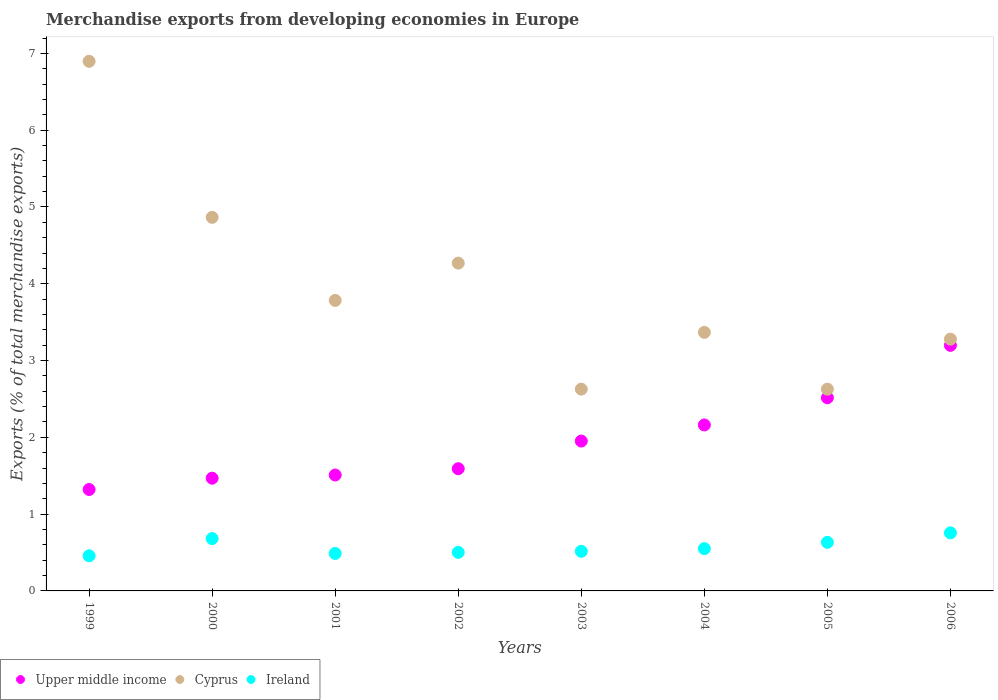How many different coloured dotlines are there?
Offer a terse response. 3. What is the percentage of total merchandise exports in Cyprus in 2005?
Your answer should be compact. 2.63. Across all years, what is the maximum percentage of total merchandise exports in Upper middle income?
Keep it short and to the point. 3.2. Across all years, what is the minimum percentage of total merchandise exports in Ireland?
Offer a very short reply. 0.46. In which year was the percentage of total merchandise exports in Ireland maximum?
Give a very brief answer. 2006. In which year was the percentage of total merchandise exports in Upper middle income minimum?
Keep it short and to the point. 1999. What is the total percentage of total merchandise exports in Ireland in the graph?
Your answer should be very brief. 4.58. What is the difference between the percentage of total merchandise exports in Ireland in 2001 and that in 2003?
Offer a terse response. -0.03. What is the difference between the percentage of total merchandise exports in Upper middle income in 2005 and the percentage of total merchandise exports in Ireland in 2000?
Your answer should be compact. 1.83. What is the average percentage of total merchandise exports in Upper middle income per year?
Your answer should be compact. 1.96. In the year 2000, what is the difference between the percentage of total merchandise exports in Ireland and percentage of total merchandise exports in Upper middle income?
Provide a succinct answer. -0.79. In how many years, is the percentage of total merchandise exports in Cyprus greater than 4.6 %?
Provide a succinct answer. 2. What is the ratio of the percentage of total merchandise exports in Ireland in 2000 to that in 2006?
Keep it short and to the point. 0.9. What is the difference between the highest and the second highest percentage of total merchandise exports in Ireland?
Offer a terse response. 0.07. What is the difference between the highest and the lowest percentage of total merchandise exports in Cyprus?
Make the answer very short. 4.27. In how many years, is the percentage of total merchandise exports in Upper middle income greater than the average percentage of total merchandise exports in Upper middle income taken over all years?
Your answer should be compact. 3. Is the sum of the percentage of total merchandise exports in Ireland in 2003 and 2005 greater than the maximum percentage of total merchandise exports in Cyprus across all years?
Make the answer very short. No. Is it the case that in every year, the sum of the percentage of total merchandise exports in Ireland and percentage of total merchandise exports in Cyprus  is greater than the percentage of total merchandise exports in Upper middle income?
Make the answer very short. Yes. Does the percentage of total merchandise exports in Upper middle income monotonically increase over the years?
Offer a terse response. Yes. Is the percentage of total merchandise exports in Cyprus strictly less than the percentage of total merchandise exports in Upper middle income over the years?
Offer a very short reply. No. How many dotlines are there?
Give a very brief answer. 3. How many years are there in the graph?
Keep it short and to the point. 8. What is the difference between two consecutive major ticks on the Y-axis?
Offer a terse response. 1. Are the values on the major ticks of Y-axis written in scientific E-notation?
Keep it short and to the point. No. Does the graph contain grids?
Offer a very short reply. No. How many legend labels are there?
Provide a succinct answer. 3. What is the title of the graph?
Provide a short and direct response. Merchandise exports from developing economies in Europe. Does "East Asia (developing only)" appear as one of the legend labels in the graph?
Give a very brief answer. No. What is the label or title of the X-axis?
Make the answer very short. Years. What is the label or title of the Y-axis?
Ensure brevity in your answer.  Exports (% of total merchandise exports). What is the Exports (% of total merchandise exports) of Upper middle income in 1999?
Provide a short and direct response. 1.32. What is the Exports (% of total merchandise exports) in Cyprus in 1999?
Keep it short and to the point. 6.9. What is the Exports (% of total merchandise exports) in Ireland in 1999?
Give a very brief answer. 0.46. What is the Exports (% of total merchandise exports) in Upper middle income in 2000?
Your answer should be compact. 1.47. What is the Exports (% of total merchandise exports) in Cyprus in 2000?
Provide a succinct answer. 4.87. What is the Exports (% of total merchandise exports) of Ireland in 2000?
Offer a terse response. 0.68. What is the Exports (% of total merchandise exports) of Upper middle income in 2001?
Keep it short and to the point. 1.51. What is the Exports (% of total merchandise exports) of Cyprus in 2001?
Give a very brief answer. 3.78. What is the Exports (% of total merchandise exports) of Ireland in 2001?
Offer a very short reply. 0.49. What is the Exports (% of total merchandise exports) of Upper middle income in 2002?
Make the answer very short. 1.59. What is the Exports (% of total merchandise exports) of Cyprus in 2002?
Provide a succinct answer. 4.27. What is the Exports (% of total merchandise exports) of Ireland in 2002?
Give a very brief answer. 0.5. What is the Exports (% of total merchandise exports) of Upper middle income in 2003?
Provide a short and direct response. 1.95. What is the Exports (% of total merchandise exports) of Cyprus in 2003?
Give a very brief answer. 2.63. What is the Exports (% of total merchandise exports) in Ireland in 2003?
Ensure brevity in your answer.  0.52. What is the Exports (% of total merchandise exports) of Upper middle income in 2004?
Offer a terse response. 2.16. What is the Exports (% of total merchandise exports) in Cyprus in 2004?
Provide a short and direct response. 3.37. What is the Exports (% of total merchandise exports) of Ireland in 2004?
Offer a very short reply. 0.55. What is the Exports (% of total merchandise exports) of Upper middle income in 2005?
Provide a succinct answer. 2.52. What is the Exports (% of total merchandise exports) of Cyprus in 2005?
Ensure brevity in your answer.  2.63. What is the Exports (% of total merchandise exports) in Ireland in 2005?
Provide a succinct answer. 0.63. What is the Exports (% of total merchandise exports) in Upper middle income in 2006?
Your answer should be compact. 3.2. What is the Exports (% of total merchandise exports) of Cyprus in 2006?
Provide a succinct answer. 3.28. What is the Exports (% of total merchandise exports) of Ireland in 2006?
Your answer should be very brief. 0.76. Across all years, what is the maximum Exports (% of total merchandise exports) of Upper middle income?
Your answer should be compact. 3.2. Across all years, what is the maximum Exports (% of total merchandise exports) of Cyprus?
Ensure brevity in your answer.  6.9. Across all years, what is the maximum Exports (% of total merchandise exports) in Ireland?
Your answer should be very brief. 0.76. Across all years, what is the minimum Exports (% of total merchandise exports) in Upper middle income?
Your answer should be compact. 1.32. Across all years, what is the minimum Exports (% of total merchandise exports) in Cyprus?
Make the answer very short. 2.63. Across all years, what is the minimum Exports (% of total merchandise exports) of Ireland?
Give a very brief answer. 0.46. What is the total Exports (% of total merchandise exports) of Upper middle income in the graph?
Your answer should be compact. 15.72. What is the total Exports (% of total merchandise exports) in Cyprus in the graph?
Offer a terse response. 31.72. What is the total Exports (% of total merchandise exports) in Ireland in the graph?
Offer a terse response. 4.58. What is the difference between the Exports (% of total merchandise exports) in Upper middle income in 1999 and that in 2000?
Offer a terse response. -0.15. What is the difference between the Exports (% of total merchandise exports) in Cyprus in 1999 and that in 2000?
Provide a succinct answer. 2.03. What is the difference between the Exports (% of total merchandise exports) in Ireland in 1999 and that in 2000?
Your response must be concise. -0.22. What is the difference between the Exports (% of total merchandise exports) in Upper middle income in 1999 and that in 2001?
Keep it short and to the point. -0.19. What is the difference between the Exports (% of total merchandise exports) in Cyprus in 1999 and that in 2001?
Ensure brevity in your answer.  3.11. What is the difference between the Exports (% of total merchandise exports) of Ireland in 1999 and that in 2001?
Your response must be concise. -0.03. What is the difference between the Exports (% of total merchandise exports) in Upper middle income in 1999 and that in 2002?
Your answer should be compact. -0.27. What is the difference between the Exports (% of total merchandise exports) of Cyprus in 1999 and that in 2002?
Your answer should be very brief. 2.63. What is the difference between the Exports (% of total merchandise exports) in Ireland in 1999 and that in 2002?
Offer a very short reply. -0.04. What is the difference between the Exports (% of total merchandise exports) of Upper middle income in 1999 and that in 2003?
Keep it short and to the point. -0.63. What is the difference between the Exports (% of total merchandise exports) of Cyprus in 1999 and that in 2003?
Keep it short and to the point. 4.27. What is the difference between the Exports (% of total merchandise exports) of Ireland in 1999 and that in 2003?
Provide a short and direct response. -0.06. What is the difference between the Exports (% of total merchandise exports) in Upper middle income in 1999 and that in 2004?
Ensure brevity in your answer.  -0.84. What is the difference between the Exports (% of total merchandise exports) in Cyprus in 1999 and that in 2004?
Provide a short and direct response. 3.53. What is the difference between the Exports (% of total merchandise exports) of Ireland in 1999 and that in 2004?
Make the answer very short. -0.09. What is the difference between the Exports (% of total merchandise exports) of Upper middle income in 1999 and that in 2005?
Ensure brevity in your answer.  -1.19. What is the difference between the Exports (% of total merchandise exports) in Cyprus in 1999 and that in 2005?
Give a very brief answer. 4.27. What is the difference between the Exports (% of total merchandise exports) of Ireland in 1999 and that in 2005?
Your answer should be very brief. -0.17. What is the difference between the Exports (% of total merchandise exports) of Upper middle income in 1999 and that in 2006?
Give a very brief answer. -1.88. What is the difference between the Exports (% of total merchandise exports) of Cyprus in 1999 and that in 2006?
Offer a terse response. 3.62. What is the difference between the Exports (% of total merchandise exports) in Ireland in 1999 and that in 2006?
Your answer should be compact. -0.3. What is the difference between the Exports (% of total merchandise exports) of Upper middle income in 2000 and that in 2001?
Your answer should be very brief. -0.04. What is the difference between the Exports (% of total merchandise exports) in Cyprus in 2000 and that in 2001?
Make the answer very short. 1.08. What is the difference between the Exports (% of total merchandise exports) of Ireland in 2000 and that in 2001?
Make the answer very short. 0.19. What is the difference between the Exports (% of total merchandise exports) in Upper middle income in 2000 and that in 2002?
Your answer should be very brief. -0.12. What is the difference between the Exports (% of total merchandise exports) in Cyprus in 2000 and that in 2002?
Offer a very short reply. 0.6. What is the difference between the Exports (% of total merchandise exports) in Ireland in 2000 and that in 2002?
Make the answer very short. 0.18. What is the difference between the Exports (% of total merchandise exports) of Upper middle income in 2000 and that in 2003?
Make the answer very short. -0.48. What is the difference between the Exports (% of total merchandise exports) in Cyprus in 2000 and that in 2003?
Your response must be concise. 2.24. What is the difference between the Exports (% of total merchandise exports) in Ireland in 2000 and that in 2003?
Your response must be concise. 0.17. What is the difference between the Exports (% of total merchandise exports) in Upper middle income in 2000 and that in 2004?
Make the answer very short. -0.69. What is the difference between the Exports (% of total merchandise exports) of Cyprus in 2000 and that in 2004?
Your answer should be very brief. 1.5. What is the difference between the Exports (% of total merchandise exports) in Ireland in 2000 and that in 2004?
Ensure brevity in your answer.  0.13. What is the difference between the Exports (% of total merchandise exports) of Upper middle income in 2000 and that in 2005?
Give a very brief answer. -1.05. What is the difference between the Exports (% of total merchandise exports) in Cyprus in 2000 and that in 2005?
Keep it short and to the point. 2.24. What is the difference between the Exports (% of total merchandise exports) of Ireland in 2000 and that in 2005?
Offer a very short reply. 0.05. What is the difference between the Exports (% of total merchandise exports) of Upper middle income in 2000 and that in 2006?
Offer a very short reply. -1.73. What is the difference between the Exports (% of total merchandise exports) of Cyprus in 2000 and that in 2006?
Your answer should be very brief. 1.59. What is the difference between the Exports (% of total merchandise exports) in Ireland in 2000 and that in 2006?
Offer a terse response. -0.07. What is the difference between the Exports (% of total merchandise exports) of Upper middle income in 2001 and that in 2002?
Your answer should be very brief. -0.08. What is the difference between the Exports (% of total merchandise exports) in Cyprus in 2001 and that in 2002?
Provide a short and direct response. -0.49. What is the difference between the Exports (% of total merchandise exports) in Ireland in 2001 and that in 2002?
Your answer should be compact. -0.01. What is the difference between the Exports (% of total merchandise exports) in Upper middle income in 2001 and that in 2003?
Provide a succinct answer. -0.44. What is the difference between the Exports (% of total merchandise exports) of Cyprus in 2001 and that in 2003?
Your response must be concise. 1.16. What is the difference between the Exports (% of total merchandise exports) of Ireland in 2001 and that in 2003?
Offer a terse response. -0.03. What is the difference between the Exports (% of total merchandise exports) in Upper middle income in 2001 and that in 2004?
Provide a short and direct response. -0.65. What is the difference between the Exports (% of total merchandise exports) in Cyprus in 2001 and that in 2004?
Your answer should be compact. 0.42. What is the difference between the Exports (% of total merchandise exports) in Ireland in 2001 and that in 2004?
Offer a very short reply. -0.06. What is the difference between the Exports (% of total merchandise exports) of Upper middle income in 2001 and that in 2005?
Your answer should be compact. -1.01. What is the difference between the Exports (% of total merchandise exports) in Cyprus in 2001 and that in 2005?
Your answer should be compact. 1.16. What is the difference between the Exports (% of total merchandise exports) in Ireland in 2001 and that in 2005?
Your response must be concise. -0.14. What is the difference between the Exports (% of total merchandise exports) of Upper middle income in 2001 and that in 2006?
Your answer should be compact. -1.69. What is the difference between the Exports (% of total merchandise exports) in Cyprus in 2001 and that in 2006?
Offer a very short reply. 0.5. What is the difference between the Exports (% of total merchandise exports) in Ireland in 2001 and that in 2006?
Keep it short and to the point. -0.27. What is the difference between the Exports (% of total merchandise exports) of Upper middle income in 2002 and that in 2003?
Offer a very short reply. -0.36. What is the difference between the Exports (% of total merchandise exports) of Cyprus in 2002 and that in 2003?
Ensure brevity in your answer.  1.64. What is the difference between the Exports (% of total merchandise exports) in Ireland in 2002 and that in 2003?
Offer a very short reply. -0.01. What is the difference between the Exports (% of total merchandise exports) of Upper middle income in 2002 and that in 2004?
Offer a terse response. -0.57. What is the difference between the Exports (% of total merchandise exports) in Cyprus in 2002 and that in 2004?
Your answer should be compact. 0.9. What is the difference between the Exports (% of total merchandise exports) in Ireland in 2002 and that in 2004?
Ensure brevity in your answer.  -0.05. What is the difference between the Exports (% of total merchandise exports) in Upper middle income in 2002 and that in 2005?
Your answer should be very brief. -0.92. What is the difference between the Exports (% of total merchandise exports) of Cyprus in 2002 and that in 2005?
Your response must be concise. 1.64. What is the difference between the Exports (% of total merchandise exports) in Ireland in 2002 and that in 2005?
Keep it short and to the point. -0.13. What is the difference between the Exports (% of total merchandise exports) in Upper middle income in 2002 and that in 2006?
Ensure brevity in your answer.  -1.61. What is the difference between the Exports (% of total merchandise exports) of Cyprus in 2002 and that in 2006?
Provide a short and direct response. 0.99. What is the difference between the Exports (% of total merchandise exports) of Ireland in 2002 and that in 2006?
Provide a succinct answer. -0.25. What is the difference between the Exports (% of total merchandise exports) in Upper middle income in 2003 and that in 2004?
Keep it short and to the point. -0.21. What is the difference between the Exports (% of total merchandise exports) in Cyprus in 2003 and that in 2004?
Provide a succinct answer. -0.74. What is the difference between the Exports (% of total merchandise exports) of Ireland in 2003 and that in 2004?
Ensure brevity in your answer.  -0.03. What is the difference between the Exports (% of total merchandise exports) in Upper middle income in 2003 and that in 2005?
Give a very brief answer. -0.56. What is the difference between the Exports (% of total merchandise exports) in Cyprus in 2003 and that in 2005?
Offer a very short reply. 0. What is the difference between the Exports (% of total merchandise exports) of Ireland in 2003 and that in 2005?
Make the answer very short. -0.12. What is the difference between the Exports (% of total merchandise exports) in Upper middle income in 2003 and that in 2006?
Make the answer very short. -1.25. What is the difference between the Exports (% of total merchandise exports) of Cyprus in 2003 and that in 2006?
Offer a very short reply. -0.65. What is the difference between the Exports (% of total merchandise exports) of Ireland in 2003 and that in 2006?
Offer a terse response. -0.24. What is the difference between the Exports (% of total merchandise exports) of Upper middle income in 2004 and that in 2005?
Offer a very short reply. -0.35. What is the difference between the Exports (% of total merchandise exports) of Cyprus in 2004 and that in 2005?
Give a very brief answer. 0.74. What is the difference between the Exports (% of total merchandise exports) in Ireland in 2004 and that in 2005?
Give a very brief answer. -0.08. What is the difference between the Exports (% of total merchandise exports) of Upper middle income in 2004 and that in 2006?
Your answer should be compact. -1.04. What is the difference between the Exports (% of total merchandise exports) of Cyprus in 2004 and that in 2006?
Give a very brief answer. 0.09. What is the difference between the Exports (% of total merchandise exports) in Ireland in 2004 and that in 2006?
Your answer should be very brief. -0.21. What is the difference between the Exports (% of total merchandise exports) in Upper middle income in 2005 and that in 2006?
Your answer should be very brief. -0.68. What is the difference between the Exports (% of total merchandise exports) of Cyprus in 2005 and that in 2006?
Keep it short and to the point. -0.65. What is the difference between the Exports (% of total merchandise exports) of Ireland in 2005 and that in 2006?
Make the answer very short. -0.12. What is the difference between the Exports (% of total merchandise exports) in Upper middle income in 1999 and the Exports (% of total merchandise exports) in Cyprus in 2000?
Your response must be concise. -3.54. What is the difference between the Exports (% of total merchandise exports) of Upper middle income in 1999 and the Exports (% of total merchandise exports) of Ireland in 2000?
Provide a succinct answer. 0.64. What is the difference between the Exports (% of total merchandise exports) in Cyprus in 1999 and the Exports (% of total merchandise exports) in Ireland in 2000?
Your response must be concise. 6.22. What is the difference between the Exports (% of total merchandise exports) of Upper middle income in 1999 and the Exports (% of total merchandise exports) of Cyprus in 2001?
Provide a short and direct response. -2.46. What is the difference between the Exports (% of total merchandise exports) in Upper middle income in 1999 and the Exports (% of total merchandise exports) in Ireland in 2001?
Your answer should be very brief. 0.83. What is the difference between the Exports (% of total merchandise exports) in Cyprus in 1999 and the Exports (% of total merchandise exports) in Ireland in 2001?
Keep it short and to the point. 6.41. What is the difference between the Exports (% of total merchandise exports) in Upper middle income in 1999 and the Exports (% of total merchandise exports) in Cyprus in 2002?
Your answer should be very brief. -2.95. What is the difference between the Exports (% of total merchandise exports) of Upper middle income in 1999 and the Exports (% of total merchandise exports) of Ireland in 2002?
Give a very brief answer. 0.82. What is the difference between the Exports (% of total merchandise exports) in Cyprus in 1999 and the Exports (% of total merchandise exports) in Ireland in 2002?
Offer a terse response. 6.4. What is the difference between the Exports (% of total merchandise exports) in Upper middle income in 1999 and the Exports (% of total merchandise exports) in Cyprus in 2003?
Make the answer very short. -1.31. What is the difference between the Exports (% of total merchandise exports) in Upper middle income in 1999 and the Exports (% of total merchandise exports) in Ireland in 2003?
Give a very brief answer. 0.81. What is the difference between the Exports (% of total merchandise exports) in Cyprus in 1999 and the Exports (% of total merchandise exports) in Ireland in 2003?
Offer a very short reply. 6.38. What is the difference between the Exports (% of total merchandise exports) of Upper middle income in 1999 and the Exports (% of total merchandise exports) of Cyprus in 2004?
Your response must be concise. -2.05. What is the difference between the Exports (% of total merchandise exports) of Upper middle income in 1999 and the Exports (% of total merchandise exports) of Ireland in 2004?
Provide a short and direct response. 0.77. What is the difference between the Exports (% of total merchandise exports) in Cyprus in 1999 and the Exports (% of total merchandise exports) in Ireland in 2004?
Provide a short and direct response. 6.35. What is the difference between the Exports (% of total merchandise exports) of Upper middle income in 1999 and the Exports (% of total merchandise exports) of Cyprus in 2005?
Your answer should be very brief. -1.31. What is the difference between the Exports (% of total merchandise exports) of Upper middle income in 1999 and the Exports (% of total merchandise exports) of Ireland in 2005?
Your answer should be very brief. 0.69. What is the difference between the Exports (% of total merchandise exports) of Cyprus in 1999 and the Exports (% of total merchandise exports) of Ireland in 2005?
Ensure brevity in your answer.  6.26. What is the difference between the Exports (% of total merchandise exports) of Upper middle income in 1999 and the Exports (% of total merchandise exports) of Cyprus in 2006?
Offer a terse response. -1.96. What is the difference between the Exports (% of total merchandise exports) in Upper middle income in 1999 and the Exports (% of total merchandise exports) in Ireland in 2006?
Offer a terse response. 0.56. What is the difference between the Exports (% of total merchandise exports) of Cyprus in 1999 and the Exports (% of total merchandise exports) of Ireland in 2006?
Offer a terse response. 6.14. What is the difference between the Exports (% of total merchandise exports) in Upper middle income in 2000 and the Exports (% of total merchandise exports) in Cyprus in 2001?
Provide a succinct answer. -2.32. What is the difference between the Exports (% of total merchandise exports) of Upper middle income in 2000 and the Exports (% of total merchandise exports) of Ireland in 2001?
Offer a very short reply. 0.98. What is the difference between the Exports (% of total merchandise exports) of Cyprus in 2000 and the Exports (% of total merchandise exports) of Ireland in 2001?
Give a very brief answer. 4.38. What is the difference between the Exports (% of total merchandise exports) of Upper middle income in 2000 and the Exports (% of total merchandise exports) of Cyprus in 2002?
Offer a very short reply. -2.8. What is the difference between the Exports (% of total merchandise exports) in Upper middle income in 2000 and the Exports (% of total merchandise exports) in Ireland in 2002?
Make the answer very short. 0.97. What is the difference between the Exports (% of total merchandise exports) of Cyprus in 2000 and the Exports (% of total merchandise exports) of Ireland in 2002?
Keep it short and to the point. 4.36. What is the difference between the Exports (% of total merchandise exports) in Upper middle income in 2000 and the Exports (% of total merchandise exports) in Cyprus in 2003?
Ensure brevity in your answer.  -1.16. What is the difference between the Exports (% of total merchandise exports) of Cyprus in 2000 and the Exports (% of total merchandise exports) of Ireland in 2003?
Offer a very short reply. 4.35. What is the difference between the Exports (% of total merchandise exports) in Upper middle income in 2000 and the Exports (% of total merchandise exports) in Cyprus in 2004?
Your answer should be compact. -1.9. What is the difference between the Exports (% of total merchandise exports) of Upper middle income in 2000 and the Exports (% of total merchandise exports) of Ireland in 2004?
Make the answer very short. 0.92. What is the difference between the Exports (% of total merchandise exports) in Cyprus in 2000 and the Exports (% of total merchandise exports) in Ireland in 2004?
Your response must be concise. 4.31. What is the difference between the Exports (% of total merchandise exports) in Upper middle income in 2000 and the Exports (% of total merchandise exports) in Cyprus in 2005?
Your answer should be very brief. -1.16. What is the difference between the Exports (% of total merchandise exports) in Upper middle income in 2000 and the Exports (% of total merchandise exports) in Ireland in 2005?
Give a very brief answer. 0.84. What is the difference between the Exports (% of total merchandise exports) in Cyprus in 2000 and the Exports (% of total merchandise exports) in Ireland in 2005?
Your answer should be very brief. 4.23. What is the difference between the Exports (% of total merchandise exports) of Upper middle income in 2000 and the Exports (% of total merchandise exports) of Cyprus in 2006?
Keep it short and to the point. -1.81. What is the difference between the Exports (% of total merchandise exports) in Upper middle income in 2000 and the Exports (% of total merchandise exports) in Ireland in 2006?
Make the answer very short. 0.71. What is the difference between the Exports (% of total merchandise exports) in Cyprus in 2000 and the Exports (% of total merchandise exports) in Ireland in 2006?
Your answer should be compact. 4.11. What is the difference between the Exports (% of total merchandise exports) of Upper middle income in 2001 and the Exports (% of total merchandise exports) of Cyprus in 2002?
Your response must be concise. -2.76. What is the difference between the Exports (% of total merchandise exports) of Upper middle income in 2001 and the Exports (% of total merchandise exports) of Ireland in 2002?
Ensure brevity in your answer.  1.01. What is the difference between the Exports (% of total merchandise exports) in Cyprus in 2001 and the Exports (% of total merchandise exports) in Ireland in 2002?
Offer a very short reply. 3.28. What is the difference between the Exports (% of total merchandise exports) in Upper middle income in 2001 and the Exports (% of total merchandise exports) in Cyprus in 2003?
Your response must be concise. -1.12. What is the difference between the Exports (% of total merchandise exports) in Cyprus in 2001 and the Exports (% of total merchandise exports) in Ireland in 2003?
Make the answer very short. 3.27. What is the difference between the Exports (% of total merchandise exports) in Upper middle income in 2001 and the Exports (% of total merchandise exports) in Cyprus in 2004?
Offer a very short reply. -1.86. What is the difference between the Exports (% of total merchandise exports) of Upper middle income in 2001 and the Exports (% of total merchandise exports) of Ireland in 2004?
Offer a very short reply. 0.96. What is the difference between the Exports (% of total merchandise exports) in Cyprus in 2001 and the Exports (% of total merchandise exports) in Ireland in 2004?
Your answer should be compact. 3.23. What is the difference between the Exports (% of total merchandise exports) in Upper middle income in 2001 and the Exports (% of total merchandise exports) in Cyprus in 2005?
Provide a succinct answer. -1.12. What is the difference between the Exports (% of total merchandise exports) of Upper middle income in 2001 and the Exports (% of total merchandise exports) of Ireland in 2005?
Your answer should be compact. 0.88. What is the difference between the Exports (% of total merchandise exports) in Cyprus in 2001 and the Exports (% of total merchandise exports) in Ireland in 2005?
Your answer should be very brief. 3.15. What is the difference between the Exports (% of total merchandise exports) in Upper middle income in 2001 and the Exports (% of total merchandise exports) in Cyprus in 2006?
Offer a very short reply. -1.77. What is the difference between the Exports (% of total merchandise exports) of Upper middle income in 2001 and the Exports (% of total merchandise exports) of Ireland in 2006?
Offer a terse response. 0.75. What is the difference between the Exports (% of total merchandise exports) of Cyprus in 2001 and the Exports (% of total merchandise exports) of Ireland in 2006?
Make the answer very short. 3.03. What is the difference between the Exports (% of total merchandise exports) of Upper middle income in 2002 and the Exports (% of total merchandise exports) of Cyprus in 2003?
Your response must be concise. -1.04. What is the difference between the Exports (% of total merchandise exports) of Upper middle income in 2002 and the Exports (% of total merchandise exports) of Ireland in 2003?
Your answer should be very brief. 1.08. What is the difference between the Exports (% of total merchandise exports) of Cyprus in 2002 and the Exports (% of total merchandise exports) of Ireland in 2003?
Keep it short and to the point. 3.75. What is the difference between the Exports (% of total merchandise exports) in Upper middle income in 2002 and the Exports (% of total merchandise exports) in Cyprus in 2004?
Your answer should be compact. -1.78. What is the difference between the Exports (% of total merchandise exports) in Upper middle income in 2002 and the Exports (% of total merchandise exports) in Ireland in 2004?
Keep it short and to the point. 1.04. What is the difference between the Exports (% of total merchandise exports) of Cyprus in 2002 and the Exports (% of total merchandise exports) of Ireland in 2004?
Ensure brevity in your answer.  3.72. What is the difference between the Exports (% of total merchandise exports) in Upper middle income in 2002 and the Exports (% of total merchandise exports) in Cyprus in 2005?
Your answer should be compact. -1.04. What is the difference between the Exports (% of total merchandise exports) of Upper middle income in 2002 and the Exports (% of total merchandise exports) of Ireland in 2005?
Your answer should be compact. 0.96. What is the difference between the Exports (% of total merchandise exports) of Cyprus in 2002 and the Exports (% of total merchandise exports) of Ireland in 2005?
Your response must be concise. 3.64. What is the difference between the Exports (% of total merchandise exports) in Upper middle income in 2002 and the Exports (% of total merchandise exports) in Cyprus in 2006?
Offer a terse response. -1.69. What is the difference between the Exports (% of total merchandise exports) in Upper middle income in 2002 and the Exports (% of total merchandise exports) in Ireland in 2006?
Offer a terse response. 0.84. What is the difference between the Exports (% of total merchandise exports) of Cyprus in 2002 and the Exports (% of total merchandise exports) of Ireland in 2006?
Provide a short and direct response. 3.51. What is the difference between the Exports (% of total merchandise exports) of Upper middle income in 2003 and the Exports (% of total merchandise exports) of Cyprus in 2004?
Offer a very short reply. -1.42. What is the difference between the Exports (% of total merchandise exports) of Upper middle income in 2003 and the Exports (% of total merchandise exports) of Ireland in 2004?
Make the answer very short. 1.4. What is the difference between the Exports (% of total merchandise exports) in Cyprus in 2003 and the Exports (% of total merchandise exports) in Ireland in 2004?
Offer a very short reply. 2.08. What is the difference between the Exports (% of total merchandise exports) of Upper middle income in 2003 and the Exports (% of total merchandise exports) of Cyprus in 2005?
Offer a very short reply. -0.68. What is the difference between the Exports (% of total merchandise exports) of Upper middle income in 2003 and the Exports (% of total merchandise exports) of Ireland in 2005?
Offer a terse response. 1.32. What is the difference between the Exports (% of total merchandise exports) in Cyprus in 2003 and the Exports (% of total merchandise exports) in Ireland in 2005?
Give a very brief answer. 2. What is the difference between the Exports (% of total merchandise exports) in Upper middle income in 2003 and the Exports (% of total merchandise exports) in Cyprus in 2006?
Provide a short and direct response. -1.33. What is the difference between the Exports (% of total merchandise exports) in Upper middle income in 2003 and the Exports (% of total merchandise exports) in Ireland in 2006?
Make the answer very short. 1.2. What is the difference between the Exports (% of total merchandise exports) in Cyprus in 2003 and the Exports (% of total merchandise exports) in Ireland in 2006?
Make the answer very short. 1.87. What is the difference between the Exports (% of total merchandise exports) of Upper middle income in 2004 and the Exports (% of total merchandise exports) of Cyprus in 2005?
Your response must be concise. -0.47. What is the difference between the Exports (% of total merchandise exports) in Upper middle income in 2004 and the Exports (% of total merchandise exports) in Ireland in 2005?
Provide a succinct answer. 1.53. What is the difference between the Exports (% of total merchandise exports) of Cyprus in 2004 and the Exports (% of total merchandise exports) of Ireland in 2005?
Offer a very short reply. 2.73. What is the difference between the Exports (% of total merchandise exports) of Upper middle income in 2004 and the Exports (% of total merchandise exports) of Cyprus in 2006?
Keep it short and to the point. -1.12. What is the difference between the Exports (% of total merchandise exports) in Upper middle income in 2004 and the Exports (% of total merchandise exports) in Ireland in 2006?
Make the answer very short. 1.41. What is the difference between the Exports (% of total merchandise exports) in Cyprus in 2004 and the Exports (% of total merchandise exports) in Ireland in 2006?
Ensure brevity in your answer.  2.61. What is the difference between the Exports (% of total merchandise exports) of Upper middle income in 2005 and the Exports (% of total merchandise exports) of Cyprus in 2006?
Provide a succinct answer. -0.76. What is the difference between the Exports (% of total merchandise exports) of Upper middle income in 2005 and the Exports (% of total merchandise exports) of Ireland in 2006?
Offer a very short reply. 1.76. What is the difference between the Exports (% of total merchandise exports) of Cyprus in 2005 and the Exports (% of total merchandise exports) of Ireland in 2006?
Offer a terse response. 1.87. What is the average Exports (% of total merchandise exports) in Upper middle income per year?
Your answer should be compact. 1.96. What is the average Exports (% of total merchandise exports) in Cyprus per year?
Your answer should be very brief. 3.96. What is the average Exports (% of total merchandise exports) of Ireland per year?
Your response must be concise. 0.57. In the year 1999, what is the difference between the Exports (% of total merchandise exports) in Upper middle income and Exports (% of total merchandise exports) in Cyprus?
Offer a terse response. -5.58. In the year 1999, what is the difference between the Exports (% of total merchandise exports) in Upper middle income and Exports (% of total merchandise exports) in Ireland?
Offer a terse response. 0.86. In the year 1999, what is the difference between the Exports (% of total merchandise exports) in Cyprus and Exports (% of total merchandise exports) in Ireland?
Make the answer very short. 6.44. In the year 2000, what is the difference between the Exports (% of total merchandise exports) in Upper middle income and Exports (% of total merchandise exports) in Cyprus?
Offer a very short reply. -3.4. In the year 2000, what is the difference between the Exports (% of total merchandise exports) in Upper middle income and Exports (% of total merchandise exports) in Ireland?
Make the answer very short. 0.79. In the year 2000, what is the difference between the Exports (% of total merchandise exports) in Cyprus and Exports (% of total merchandise exports) in Ireland?
Give a very brief answer. 4.18. In the year 2001, what is the difference between the Exports (% of total merchandise exports) in Upper middle income and Exports (% of total merchandise exports) in Cyprus?
Ensure brevity in your answer.  -2.27. In the year 2001, what is the difference between the Exports (% of total merchandise exports) of Upper middle income and Exports (% of total merchandise exports) of Ireland?
Your answer should be very brief. 1.02. In the year 2001, what is the difference between the Exports (% of total merchandise exports) in Cyprus and Exports (% of total merchandise exports) in Ireland?
Provide a succinct answer. 3.3. In the year 2002, what is the difference between the Exports (% of total merchandise exports) in Upper middle income and Exports (% of total merchandise exports) in Cyprus?
Your answer should be very brief. -2.68. In the year 2002, what is the difference between the Exports (% of total merchandise exports) of Upper middle income and Exports (% of total merchandise exports) of Ireland?
Keep it short and to the point. 1.09. In the year 2002, what is the difference between the Exports (% of total merchandise exports) in Cyprus and Exports (% of total merchandise exports) in Ireland?
Provide a succinct answer. 3.77. In the year 2003, what is the difference between the Exports (% of total merchandise exports) of Upper middle income and Exports (% of total merchandise exports) of Cyprus?
Your answer should be compact. -0.68. In the year 2003, what is the difference between the Exports (% of total merchandise exports) in Upper middle income and Exports (% of total merchandise exports) in Ireland?
Keep it short and to the point. 1.44. In the year 2003, what is the difference between the Exports (% of total merchandise exports) of Cyprus and Exports (% of total merchandise exports) of Ireland?
Keep it short and to the point. 2.11. In the year 2004, what is the difference between the Exports (% of total merchandise exports) in Upper middle income and Exports (% of total merchandise exports) in Cyprus?
Your response must be concise. -1.21. In the year 2004, what is the difference between the Exports (% of total merchandise exports) of Upper middle income and Exports (% of total merchandise exports) of Ireland?
Offer a terse response. 1.61. In the year 2004, what is the difference between the Exports (% of total merchandise exports) in Cyprus and Exports (% of total merchandise exports) in Ireland?
Offer a very short reply. 2.82. In the year 2005, what is the difference between the Exports (% of total merchandise exports) of Upper middle income and Exports (% of total merchandise exports) of Cyprus?
Make the answer very short. -0.11. In the year 2005, what is the difference between the Exports (% of total merchandise exports) in Upper middle income and Exports (% of total merchandise exports) in Ireland?
Offer a terse response. 1.88. In the year 2005, what is the difference between the Exports (% of total merchandise exports) of Cyprus and Exports (% of total merchandise exports) of Ireland?
Ensure brevity in your answer.  1.99. In the year 2006, what is the difference between the Exports (% of total merchandise exports) of Upper middle income and Exports (% of total merchandise exports) of Cyprus?
Provide a short and direct response. -0.08. In the year 2006, what is the difference between the Exports (% of total merchandise exports) of Upper middle income and Exports (% of total merchandise exports) of Ireland?
Offer a terse response. 2.44. In the year 2006, what is the difference between the Exports (% of total merchandise exports) of Cyprus and Exports (% of total merchandise exports) of Ireland?
Provide a succinct answer. 2.52. What is the ratio of the Exports (% of total merchandise exports) of Upper middle income in 1999 to that in 2000?
Give a very brief answer. 0.9. What is the ratio of the Exports (% of total merchandise exports) of Cyprus in 1999 to that in 2000?
Offer a terse response. 1.42. What is the ratio of the Exports (% of total merchandise exports) of Ireland in 1999 to that in 2000?
Ensure brevity in your answer.  0.67. What is the ratio of the Exports (% of total merchandise exports) in Upper middle income in 1999 to that in 2001?
Make the answer very short. 0.88. What is the ratio of the Exports (% of total merchandise exports) of Cyprus in 1999 to that in 2001?
Your response must be concise. 1.82. What is the ratio of the Exports (% of total merchandise exports) of Ireland in 1999 to that in 2001?
Give a very brief answer. 0.94. What is the ratio of the Exports (% of total merchandise exports) in Upper middle income in 1999 to that in 2002?
Your response must be concise. 0.83. What is the ratio of the Exports (% of total merchandise exports) in Cyprus in 1999 to that in 2002?
Give a very brief answer. 1.62. What is the ratio of the Exports (% of total merchandise exports) in Ireland in 1999 to that in 2002?
Your answer should be compact. 0.91. What is the ratio of the Exports (% of total merchandise exports) in Upper middle income in 1999 to that in 2003?
Keep it short and to the point. 0.68. What is the ratio of the Exports (% of total merchandise exports) of Cyprus in 1999 to that in 2003?
Keep it short and to the point. 2.62. What is the ratio of the Exports (% of total merchandise exports) of Ireland in 1999 to that in 2003?
Your answer should be very brief. 0.89. What is the ratio of the Exports (% of total merchandise exports) in Upper middle income in 1999 to that in 2004?
Your response must be concise. 0.61. What is the ratio of the Exports (% of total merchandise exports) in Cyprus in 1999 to that in 2004?
Your answer should be very brief. 2.05. What is the ratio of the Exports (% of total merchandise exports) of Ireland in 1999 to that in 2004?
Keep it short and to the point. 0.83. What is the ratio of the Exports (% of total merchandise exports) of Upper middle income in 1999 to that in 2005?
Keep it short and to the point. 0.53. What is the ratio of the Exports (% of total merchandise exports) of Cyprus in 1999 to that in 2005?
Provide a succinct answer. 2.62. What is the ratio of the Exports (% of total merchandise exports) of Ireland in 1999 to that in 2005?
Your response must be concise. 0.72. What is the ratio of the Exports (% of total merchandise exports) in Upper middle income in 1999 to that in 2006?
Ensure brevity in your answer.  0.41. What is the ratio of the Exports (% of total merchandise exports) in Cyprus in 1999 to that in 2006?
Ensure brevity in your answer.  2.1. What is the ratio of the Exports (% of total merchandise exports) in Ireland in 1999 to that in 2006?
Your answer should be very brief. 0.61. What is the ratio of the Exports (% of total merchandise exports) of Upper middle income in 2000 to that in 2001?
Your answer should be very brief. 0.97. What is the ratio of the Exports (% of total merchandise exports) in Cyprus in 2000 to that in 2001?
Your response must be concise. 1.29. What is the ratio of the Exports (% of total merchandise exports) in Ireland in 2000 to that in 2001?
Your response must be concise. 1.4. What is the ratio of the Exports (% of total merchandise exports) of Upper middle income in 2000 to that in 2002?
Your response must be concise. 0.92. What is the ratio of the Exports (% of total merchandise exports) in Cyprus in 2000 to that in 2002?
Make the answer very short. 1.14. What is the ratio of the Exports (% of total merchandise exports) of Ireland in 2000 to that in 2002?
Provide a short and direct response. 1.36. What is the ratio of the Exports (% of total merchandise exports) in Upper middle income in 2000 to that in 2003?
Make the answer very short. 0.75. What is the ratio of the Exports (% of total merchandise exports) of Cyprus in 2000 to that in 2003?
Provide a short and direct response. 1.85. What is the ratio of the Exports (% of total merchandise exports) in Ireland in 2000 to that in 2003?
Provide a succinct answer. 1.32. What is the ratio of the Exports (% of total merchandise exports) of Upper middle income in 2000 to that in 2004?
Make the answer very short. 0.68. What is the ratio of the Exports (% of total merchandise exports) in Cyprus in 2000 to that in 2004?
Make the answer very short. 1.44. What is the ratio of the Exports (% of total merchandise exports) of Ireland in 2000 to that in 2004?
Give a very brief answer. 1.24. What is the ratio of the Exports (% of total merchandise exports) of Upper middle income in 2000 to that in 2005?
Keep it short and to the point. 0.58. What is the ratio of the Exports (% of total merchandise exports) in Cyprus in 2000 to that in 2005?
Make the answer very short. 1.85. What is the ratio of the Exports (% of total merchandise exports) of Ireland in 2000 to that in 2005?
Your answer should be compact. 1.08. What is the ratio of the Exports (% of total merchandise exports) in Upper middle income in 2000 to that in 2006?
Your answer should be compact. 0.46. What is the ratio of the Exports (% of total merchandise exports) in Cyprus in 2000 to that in 2006?
Provide a short and direct response. 1.48. What is the ratio of the Exports (% of total merchandise exports) in Ireland in 2000 to that in 2006?
Provide a short and direct response. 0.9. What is the ratio of the Exports (% of total merchandise exports) of Upper middle income in 2001 to that in 2002?
Provide a short and direct response. 0.95. What is the ratio of the Exports (% of total merchandise exports) of Cyprus in 2001 to that in 2002?
Provide a succinct answer. 0.89. What is the ratio of the Exports (% of total merchandise exports) of Ireland in 2001 to that in 2002?
Provide a short and direct response. 0.97. What is the ratio of the Exports (% of total merchandise exports) in Upper middle income in 2001 to that in 2003?
Your answer should be very brief. 0.77. What is the ratio of the Exports (% of total merchandise exports) of Cyprus in 2001 to that in 2003?
Provide a short and direct response. 1.44. What is the ratio of the Exports (% of total merchandise exports) of Ireland in 2001 to that in 2003?
Provide a short and direct response. 0.95. What is the ratio of the Exports (% of total merchandise exports) of Upper middle income in 2001 to that in 2004?
Your answer should be compact. 0.7. What is the ratio of the Exports (% of total merchandise exports) of Cyprus in 2001 to that in 2004?
Keep it short and to the point. 1.12. What is the ratio of the Exports (% of total merchandise exports) in Ireland in 2001 to that in 2004?
Offer a very short reply. 0.89. What is the ratio of the Exports (% of total merchandise exports) of Upper middle income in 2001 to that in 2005?
Your answer should be very brief. 0.6. What is the ratio of the Exports (% of total merchandise exports) of Cyprus in 2001 to that in 2005?
Keep it short and to the point. 1.44. What is the ratio of the Exports (% of total merchandise exports) in Ireland in 2001 to that in 2005?
Provide a succinct answer. 0.77. What is the ratio of the Exports (% of total merchandise exports) in Upper middle income in 2001 to that in 2006?
Your answer should be compact. 0.47. What is the ratio of the Exports (% of total merchandise exports) of Cyprus in 2001 to that in 2006?
Keep it short and to the point. 1.15. What is the ratio of the Exports (% of total merchandise exports) in Ireland in 2001 to that in 2006?
Offer a terse response. 0.65. What is the ratio of the Exports (% of total merchandise exports) in Upper middle income in 2002 to that in 2003?
Ensure brevity in your answer.  0.82. What is the ratio of the Exports (% of total merchandise exports) in Cyprus in 2002 to that in 2003?
Your response must be concise. 1.62. What is the ratio of the Exports (% of total merchandise exports) of Ireland in 2002 to that in 2003?
Your answer should be very brief. 0.97. What is the ratio of the Exports (% of total merchandise exports) in Upper middle income in 2002 to that in 2004?
Keep it short and to the point. 0.74. What is the ratio of the Exports (% of total merchandise exports) in Cyprus in 2002 to that in 2004?
Your answer should be compact. 1.27. What is the ratio of the Exports (% of total merchandise exports) of Ireland in 2002 to that in 2004?
Your response must be concise. 0.91. What is the ratio of the Exports (% of total merchandise exports) in Upper middle income in 2002 to that in 2005?
Make the answer very short. 0.63. What is the ratio of the Exports (% of total merchandise exports) of Cyprus in 2002 to that in 2005?
Make the answer very short. 1.62. What is the ratio of the Exports (% of total merchandise exports) in Ireland in 2002 to that in 2005?
Your response must be concise. 0.79. What is the ratio of the Exports (% of total merchandise exports) of Upper middle income in 2002 to that in 2006?
Your answer should be very brief. 0.5. What is the ratio of the Exports (% of total merchandise exports) of Cyprus in 2002 to that in 2006?
Make the answer very short. 1.3. What is the ratio of the Exports (% of total merchandise exports) of Ireland in 2002 to that in 2006?
Offer a very short reply. 0.66. What is the ratio of the Exports (% of total merchandise exports) in Upper middle income in 2003 to that in 2004?
Your answer should be compact. 0.9. What is the ratio of the Exports (% of total merchandise exports) in Cyprus in 2003 to that in 2004?
Give a very brief answer. 0.78. What is the ratio of the Exports (% of total merchandise exports) in Ireland in 2003 to that in 2004?
Provide a succinct answer. 0.94. What is the ratio of the Exports (% of total merchandise exports) of Upper middle income in 2003 to that in 2005?
Your answer should be very brief. 0.78. What is the ratio of the Exports (% of total merchandise exports) in Cyprus in 2003 to that in 2005?
Ensure brevity in your answer.  1. What is the ratio of the Exports (% of total merchandise exports) in Ireland in 2003 to that in 2005?
Give a very brief answer. 0.82. What is the ratio of the Exports (% of total merchandise exports) of Upper middle income in 2003 to that in 2006?
Your answer should be very brief. 0.61. What is the ratio of the Exports (% of total merchandise exports) in Cyprus in 2003 to that in 2006?
Give a very brief answer. 0.8. What is the ratio of the Exports (% of total merchandise exports) of Ireland in 2003 to that in 2006?
Provide a succinct answer. 0.68. What is the ratio of the Exports (% of total merchandise exports) of Upper middle income in 2004 to that in 2005?
Offer a terse response. 0.86. What is the ratio of the Exports (% of total merchandise exports) of Cyprus in 2004 to that in 2005?
Provide a succinct answer. 1.28. What is the ratio of the Exports (% of total merchandise exports) of Ireland in 2004 to that in 2005?
Provide a short and direct response. 0.87. What is the ratio of the Exports (% of total merchandise exports) in Upper middle income in 2004 to that in 2006?
Your answer should be very brief. 0.68. What is the ratio of the Exports (% of total merchandise exports) in Cyprus in 2004 to that in 2006?
Your answer should be very brief. 1.03. What is the ratio of the Exports (% of total merchandise exports) in Ireland in 2004 to that in 2006?
Offer a very short reply. 0.73. What is the ratio of the Exports (% of total merchandise exports) in Upper middle income in 2005 to that in 2006?
Provide a short and direct response. 0.79. What is the ratio of the Exports (% of total merchandise exports) in Cyprus in 2005 to that in 2006?
Provide a short and direct response. 0.8. What is the ratio of the Exports (% of total merchandise exports) of Ireland in 2005 to that in 2006?
Provide a short and direct response. 0.84. What is the difference between the highest and the second highest Exports (% of total merchandise exports) in Upper middle income?
Your answer should be very brief. 0.68. What is the difference between the highest and the second highest Exports (% of total merchandise exports) of Cyprus?
Provide a succinct answer. 2.03. What is the difference between the highest and the second highest Exports (% of total merchandise exports) in Ireland?
Your answer should be compact. 0.07. What is the difference between the highest and the lowest Exports (% of total merchandise exports) of Upper middle income?
Ensure brevity in your answer.  1.88. What is the difference between the highest and the lowest Exports (% of total merchandise exports) in Cyprus?
Provide a succinct answer. 4.27. What is the difference between the highest and the lowest Exports (% of total merchandise exports) of Ireland?
Keep it short and to the point. 0.3. 